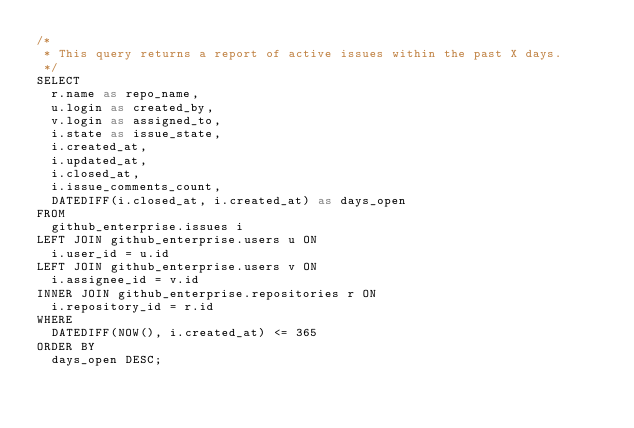Convert code to text. <code><loc_0><loc_0><loc_500><loc_500><_SQL_>/* 
 * This query returns a report of active issues within the past X days.
 */
SELECT
	r.name as repo_name,
	u.login as created_by,
	v.login as assigned_to,
	i.state as issue_state,
	i.created_at,
	i.updated_at,
	i.closed_at,
	i.issue_comments_count,
	DATEDIFF(i.closed_at, i.created_at) as days_open
FROM
	github_enterprise.issues i
LEFT JOIN github_enterprise.users u ON
	i.user_id = u.id
LEFT JOIN github_enterprise.users v ON
	i.assignee_id = v.id
INNER JOIN github_enterprise.repositories r ON
	i.repository_id = r.id
WHERE
	DATEDIFF(NOW(), i.created_at) <= 365
ORDER BY
	days_open DESC;</code> 